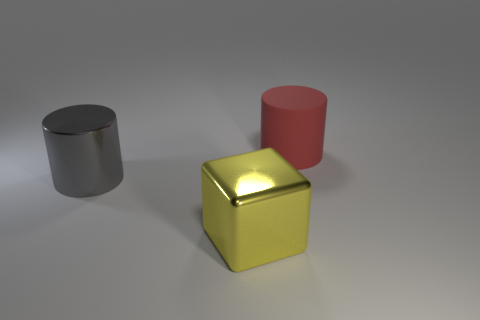Add 1 small brown shiny blocks. How many objects exist? 4 Subtract all cubes. How many objects are left? 2 Add 2 gray metallic things. How many gray metallic things exist? 3 Subtract 0 purple balls. How many objects are left? 3 Subtract all large cubes. Subtract all tiny shiny cylinders. How many objects are left? 2 Add 2 gray metal cylinders. How many gray metal cylinders are left? 3 